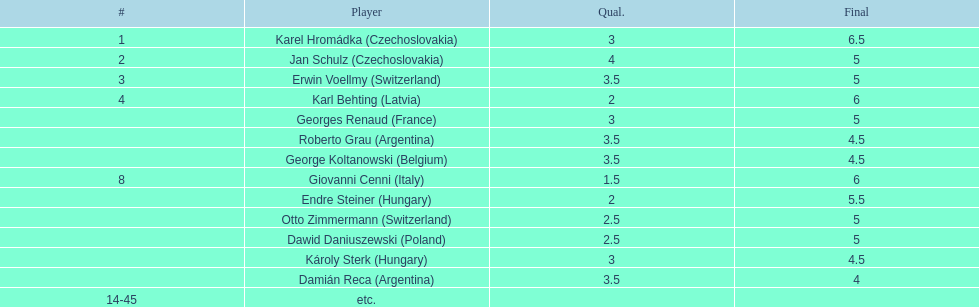Who was the top scorer from switzerland? Erwin Voellmy. 